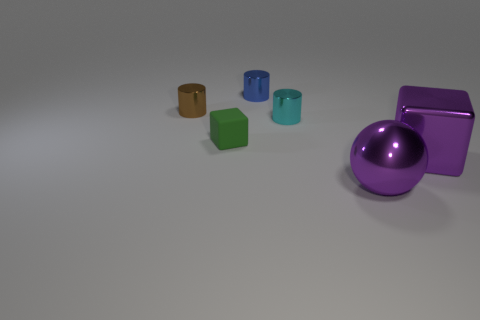There is a object behind the thing that is left of the green matte block; what is it made of?
Make the answer very short. Metal. Is there a tiny cyan object that has the same shape as the green rubber thing?
Keep it short and to the point. No. There is a shiny sphere that is the same size as the shiny block; what is its color?
Make the answer very short. Purple. How many objects are things behind the cyan shiny thing or tiny shiny objects in front of the brown shiny cylinder?
Your answer should be compact. 3. How many things are either blue metallic cylinders or cyan shiny objects?
Your answer should be very brief. 2. There is a shiny object that is both in front of the brown cylinder and behind the purple metallic cube; what is its size?
Your response must be concise. Small. How many small gray things have the same material as the large block?
Make the answer very short. 0. There is a big ball that is the same material as the purple cube; what color is it?
Ensure brevity in your answer.  Purple. Do the cylinder behind the brown metallic cylinder and the matte object have the same color?
Keep it short and to the point. No. What is the material of the cube left of the metal sphere?
Offer a terse response. Rubber. 